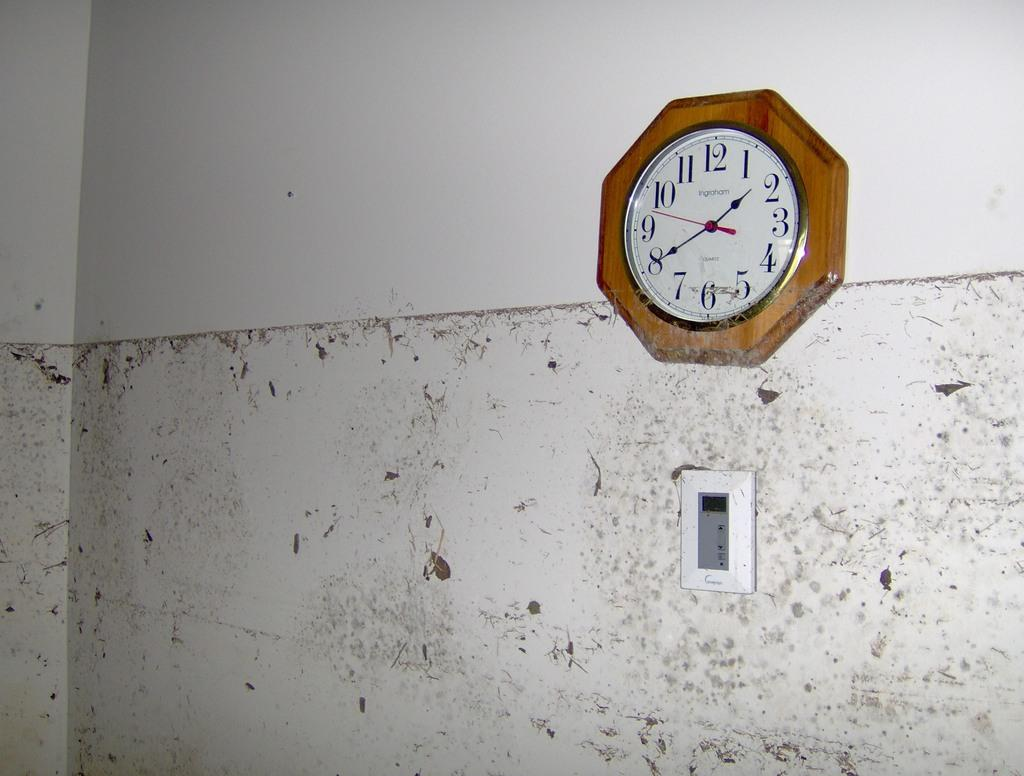<image>
Describe the image concisely. A clock made by Ingraham shows that it is 1:40. 